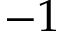Convert formula to latex. <formula><loc_0><loc_0><loc_500><loc_500>- 1</formula> 